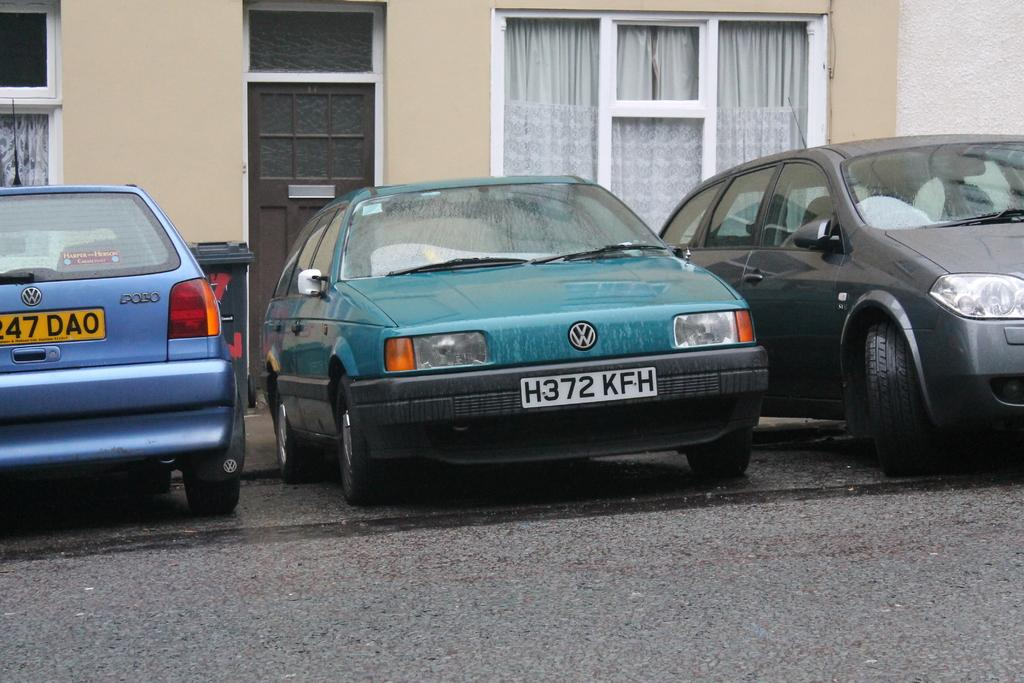What types of objects can be seen in the image? There are vehicles in the image. What can be seen beneath the vehicles? The ground is visible in the image. What type of container is present in the image? There is a trash bin in the image. What type of structure is visible in the image? There is a building with windows in the image. What type of window treatment is associated with the building? There is a curtain associated with the building in the image. What type of entrance is present in the image? There is a door in the image. Can you tell me how many bees are buzzing around the door in the image? There are no bees present in the image; the focus is on the vehicles, ground, trash bin, building, curtain, and door. 